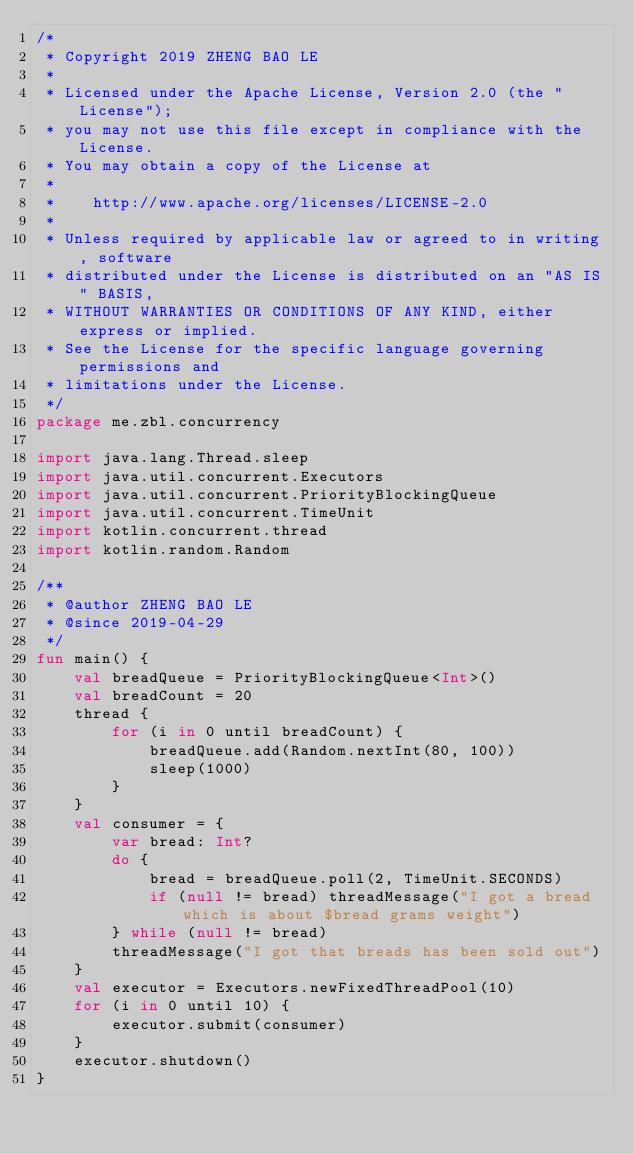Convert code to text. <code><loc_0><loc_0><loc_500><loc_500><_Kotlin_>/*
 * Copyright 2019 ZHENG BAO LE
 *
 * Licensed under the Apache License, Version 2.0 (the "License");
 * you may not use this file except in compliance with the License.
 * You may obtain a copy of the License at
 *
 *    http://www.apache.org/licenses/LICENSE-2.0
 *
 * Unless required by applicable law or agreed to in writing, software
 * distributed under the License is distributed on an "AS IS" BASIS,
 * WITHOUT WARRANTIES OR CONDITIONS OF ANY KIND, either express or implied.
 * See the License for the specific language governing permissions and
 * limitations under the License.
 */
package me.zbl.concurrency

import java.lang.Thread.sleep
import java.util.concurrent.Executors
import java.util.concurrent.PriorityBlockingQueue
import java.util.concurrent.TimeUnit
import kotlin.concurrent.thread
import kotlin.random.Random

/**
 * @author ZHENG BAO LE
 * @since 2019-04-29
 */
fun main() {
    val breadQueue = PriorityBlockingQueue<Int>()
    val breadCount = 20
    thread {
        for (i in 0 until breadCount) {
            breadQueue.add(Random.nextInt(80, 100))
            sleep(1000)
        }
    }
    val consumer = {
        var bread: Int?
        do {
            bread = breadQueue.poll(2, TimeUnit.SECONDS)
            if (null != bread) threadMessage("I got a bread which is about $bread grams weight")
        } while (null != bread)
        threadMessage("I got that breads has been sold out")
    }
    val executor = Executors.newFixedThreadPool(10)
    for (i in 0 until 10) {
        executor.submit(consumer)
    }
    executor.shutdown()
}</code> 